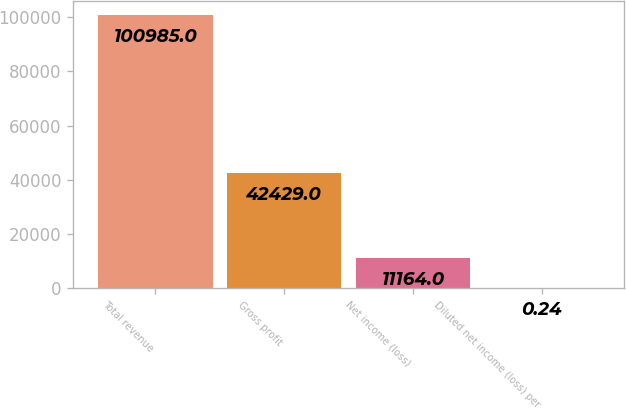Convert chart. <chart><loc_0><loc_0><loc_500><loc_500><bar_chart><fcel>Total revenue<fcel>Gross profit<fcel>Net income (loss)<fcel>Diluted net income (loss) per<nl><fcel>100985<fcel>42429<fcel>11164<fcel>0.24<nl></chart> 